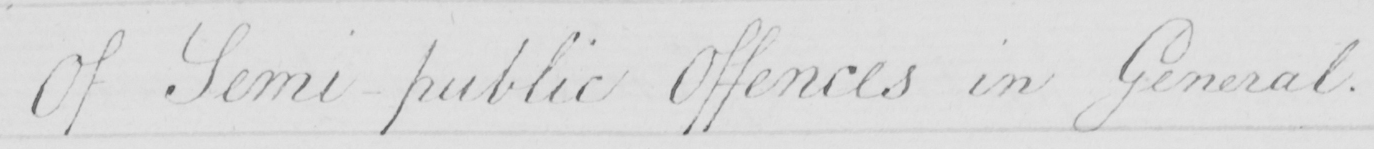Transcribe the text shown in this historical manuscript line. Of Semi-public Offences in General . 